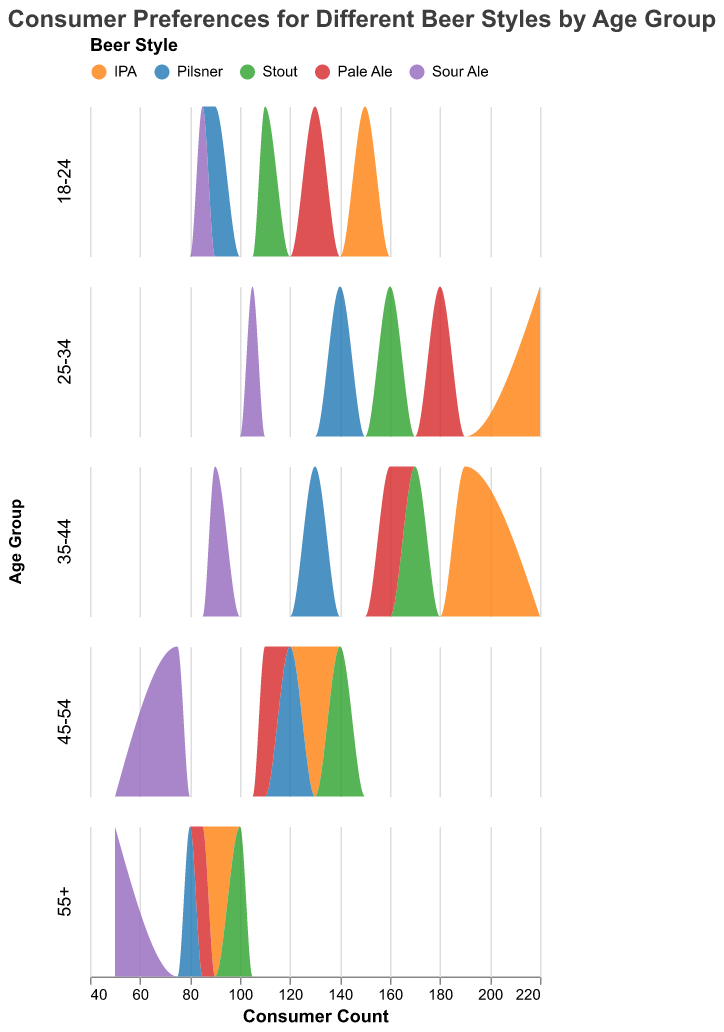What is the most preferred beer style among consumers aged 25-34? The plot shows different beer styles and their consumer counts. By looking at the density plot for the age group 25-34, we see that IPA has the highest peak compared to other styles.
Answer: IPA Which age group has the highest consumer count for Sour Ale? Compare the peaks of the Sour Ale density plots across all age groups. The 25-34 age group has the highest peak for Sour Ale.
Answer: 25-34 How does the preference for Pale Ale change as the age increases? Examine the density plots for Pale Ale across different age groups. The height of the Pale Ale peaks generally decreases as the age group increases, indicating a decline in preference.
Answer: Decreases In the age group 35-44, which two beer styles have the closest consumer count? Compare the height of the peaks for different beer styles in the 35-44 age group. Stout and Pale Ale have closely matching peaks.
Answer: Stout and Pale Ale How does the consumer count for Pilsner in the 55+ age group compare to the 18-24 age group? Look at the Pilsner peaks for both age groups. The peak for 55+ is slightly lower than the 18-24 age group, indicating fewer consumers.
Answer: Lower What is the least preferred beer style among consumers aged 18-24? By examining the density plots for the 18-24 age group, the Sour Ale has the lowest peak among the beer styles presented.
Answer: Sour Ale Which age group has the most diverse range of preferences for different beer styles? Observe the spread and variety of peaks in each age group. The 25-34 age group shows high peaks across various beer styles, indicating diverse preferences.
Answer: 25-34 Between IPA and Stout, which beer style is more popular among the 45-54 age group? Compare the peaks for IPA and Stout in the 45-54 age group. The peak for Stout is higher than that for IPA, showing more popularity.
Answer: Stout For which age group does Pilsner have the highest consumer count? Observe the density plot peaks for Pilsner across all age groups. Age group 25-34 has the highest peak for Pilsner.
Answer: 25-34 How does the consumer count for IPA change from age group 18-24 to age group 55+? Examine the density plots for IPA across these age groups. The height of the peaks decreases as age increases from 18-24 to 55+, indicating a decline in consumers.
Answer: Decreases 